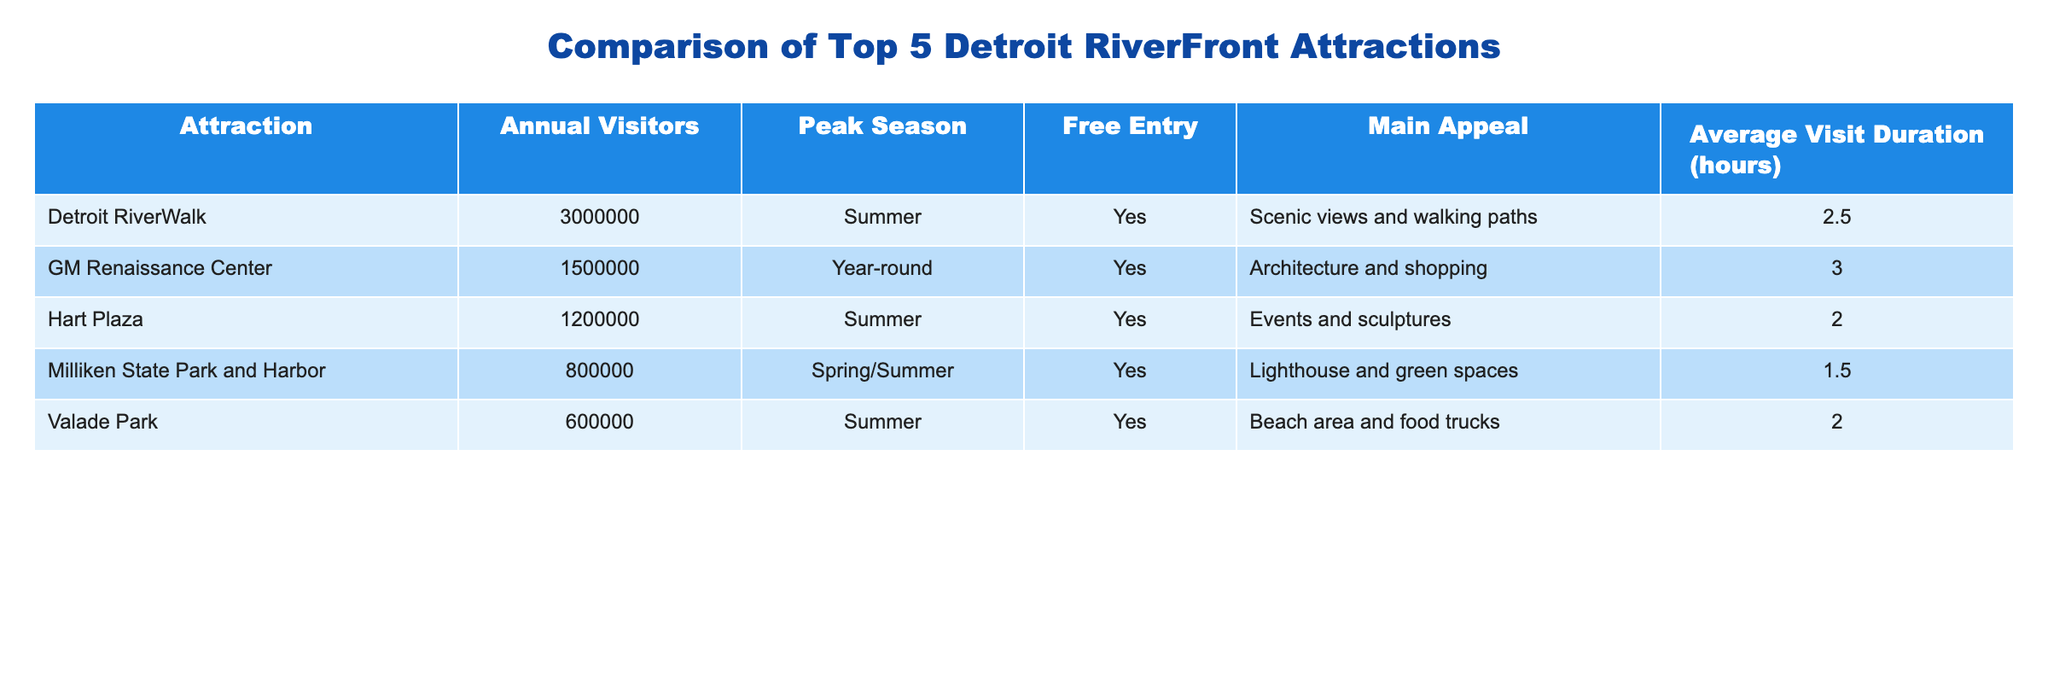What is the annual visitor count for the Detroit RiverWalk? The table lists "Detroit RiverWalk" under the "Attraction" column. The corresponding value in the "Annual Visitors" column is 3,000,000.
Answer: 3,000,000 Which attraction has the least number of annual visitors? Looking at the "Annual Visitors" column, the lowest value is 600,000, which corresponds to "Valade Park".
Answer: Valade Park How many more visitors does the GM Renaissance Center have compared to Milliken State Park and Harbor? The GM Renaissance Center has 1,500,000 visitors and Milliken State Park and Harbor has 800,000 visitors. The difference is 1,500,000 - 800,000 = 700,000.
Answer: 700,000 Is free entry available at all attractions listed in the table? Checking the "Free Entry" column, all attractions have "Yes" indicated, meaning free entry is available at each one.
Answer: Yes What is the average number of annual visitors for the top five attractions? To calculate the average, sum the annual visitors (3,000,000 + 1,500,000 + 1,200,000 + 800,000 + 600,000 = 7,100,000) and divide by 5 (7,100,000 / 5 = 1,420,000).
Answer: 1,420,000 Which attraction has the longest average visit duration, and what is that duration? The "Average Visit Duration" column indicates that the GM Renaissance Center has the longest duration, which is 3 hours.
Answer: GM Renaissance Center, 3 hours During which peak season does Hart Plaza attract the most visitors? Hart Plaza is marked to have its peak season in "Summer" in the “Peak Season” column.
Answer: Summer How many total visitors are there between the Detroit RiverWalk and GM Renaissance Center? The total visitors from both attractions are obtained by adding their visitor counts: 3,000,000 (Detroit RiverWalk) + 1,500,000 (GM Renaissance Center) = 4,500,000.
Answer: 4,500,000 What is the appeal of Milliken State Park and Harbor? The table indicates that the main appeal of Milliken State Park and Harbor is "Lighthouse and green spaces".
Answer: Lighthouse and green spaces 